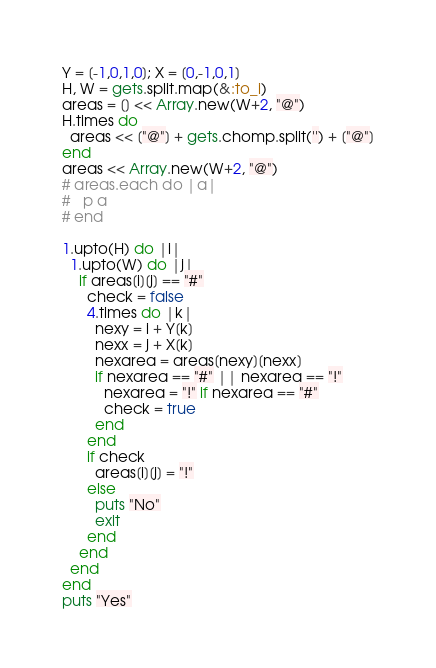Convert code to text. <code><loc_0><loc_0><loc_500><loc_500><_Ruby_>Y = [-1,0,1,0]; X = [0,-1,0,1]
H, W = gets.split.map(&:to_i)
areas = [] << Array.new(W+2, "@")
H.times do
  areas << ["@"] + gets.chomp.split('') + ["@"]
end
areas << Array.new(W+2, "@")
# areas.each do |a|
#   p a
# end

1.upto(H) do |i|
  1.upto(W) do |j|
    if areas[i][j] == "#"
      check = false
      4.times do |k|
        nexy = i + Y[k]
        nexx = j + X[k]
        nexarea = areas[nexy][nexx]
        if nexarea == "#" || nexarea == "!"
          nexarea = "!" if nexarea == "#"
          check = true
        end
      end
      if check
        areas[i][j] = "!"
      else
        puts "No"
        exit
      end
    end
  end
end
puts "Yes"</code> 